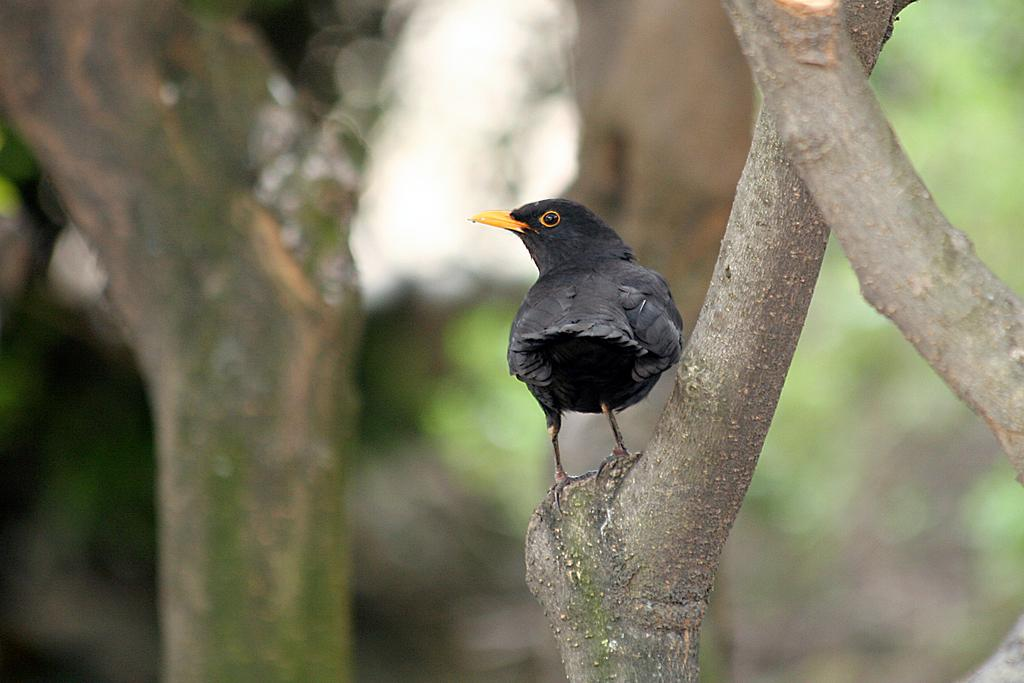What type of animal is in the image? There is a black color bird in the image. Where is the bird located? The bird is on a tree branch. Can you describe the background of the image? The background of the image is blurred. What note is the bird playing on its nose in the image? There is no note or instrument present in the image, and the bird does not have a nose. 